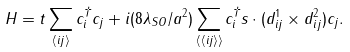Convert formula to latex. <formula><loc_0><loc_0><loc_500><loc_500>H = t \sum _ { \langle i j \rangle } c _ { i } ^ { \dagger } c _ { j } + i ( 8 \lambda _ { S O } / a ^ { 2 } ) \sum _ { \langle \langle i j \rangle \rangle } c _ { i } ^ { \dagger } { s } \cdot ( { d } _ { i j } ^ { 1 } \times { d } _ { i j } ^ { 2 } ) c _ { j } . \\</formula> 